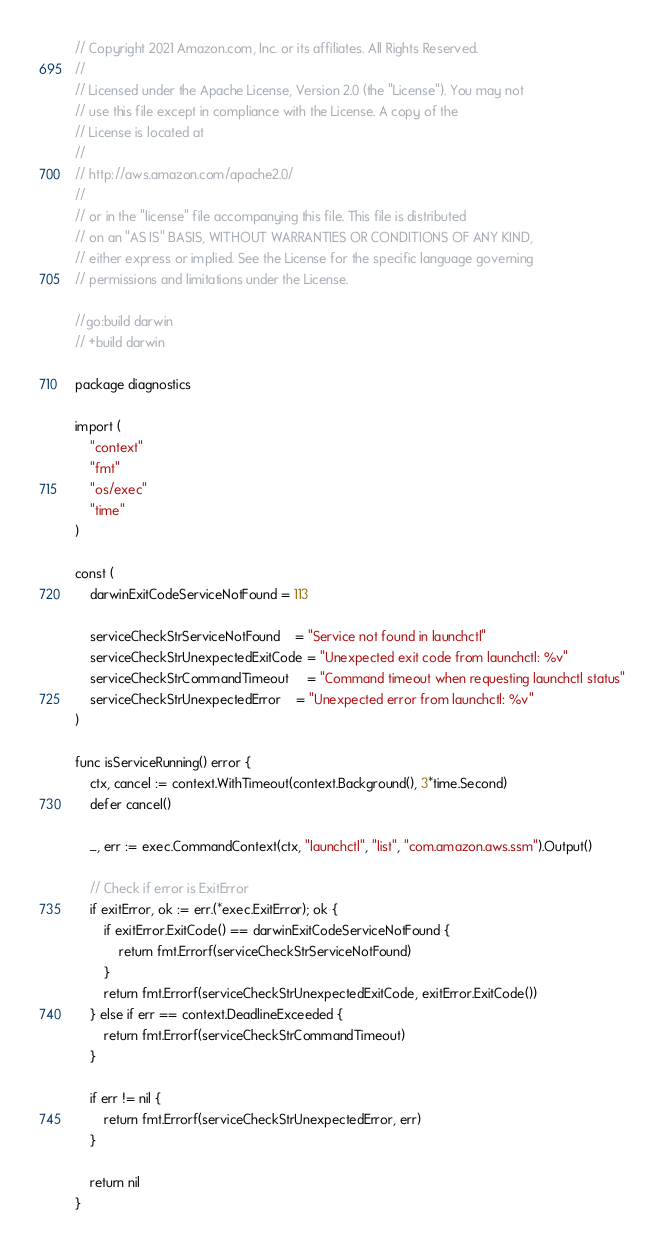<code> <loc_0><loc_0><loc_500><loc_500><_Go_>// Copyright 2021 Amazon.com, Inc. or its affiliates. All Rights Reserved.
//
// Licensed under the Apache License, Version 2.0 (the "License"). You may not
// use this file except in compliance with the License. A copy of the
// License is located at
//
// http://aws.amazon.com/apache2.0/
//
// or in the "license" file accompanying this file. This file is distributed
// on an "AS IS" BASIS, WITHOUT WARRANTIES OR CONDITIONS OF ANY KIND,
// either express or implied. See the License for the specific language governing
// permissions and limitations under the License.

//go:build darwin
// +build darwin

package diagnostics

import (
	"context"
	"fmt"
	"os/exec"
	"time"
)

const (
	darwinExitCodeServiceNotFound = 113

	serviceCheckStrServiceNotFound    = "Service not found in launchctl"
	serviceCheckStrUnexpectedExitCode = "Unexpected exit code from launchctl: %v"
	serviceCheckStrCommandTimeout     = "Command timeout when requesting launchctl status"
	serviceCheckStrUnexpectedError    = "Unexpected error from launchctl: %v"
)

func isServiceRunning() error {
	ctx, cancel := context.WithTimeout(context.Background(), 3*time.Second)
	defer cancel()

	_, err := exec.CommandContext(ctx, "launchctl", "list", "com.amazon.aws.ssm").Output()

	// Check if error is ExitError
	if exitError, ok := err.(*exec.ExitError); ok {
		if exitError.ExitCode() == darwinExitCodeServiceNotFound {
			return fmt.Errorf(serviceCheckStrServiceNotFound)
		}
		return fmt.Errorf(serviceCheckStrUnexpectedExitCode, exitError.ExitCode())
	} else if err == context.DeadlineExceeded {
		return fmt.Errorf(serviceCheckStrCommandTimeout)
	}

	if err != nil {
		return fmt.Errorf(serviceCheckStrUnexpectedError, err)
	}

	return nil
}
</code> 